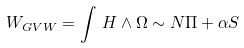<formula> <loc_0><loc_0><loc_500><loc_500>W _ { G V W } = \int \, H \wedge \Omega \sim N \Pi + \alpha S</formula> 